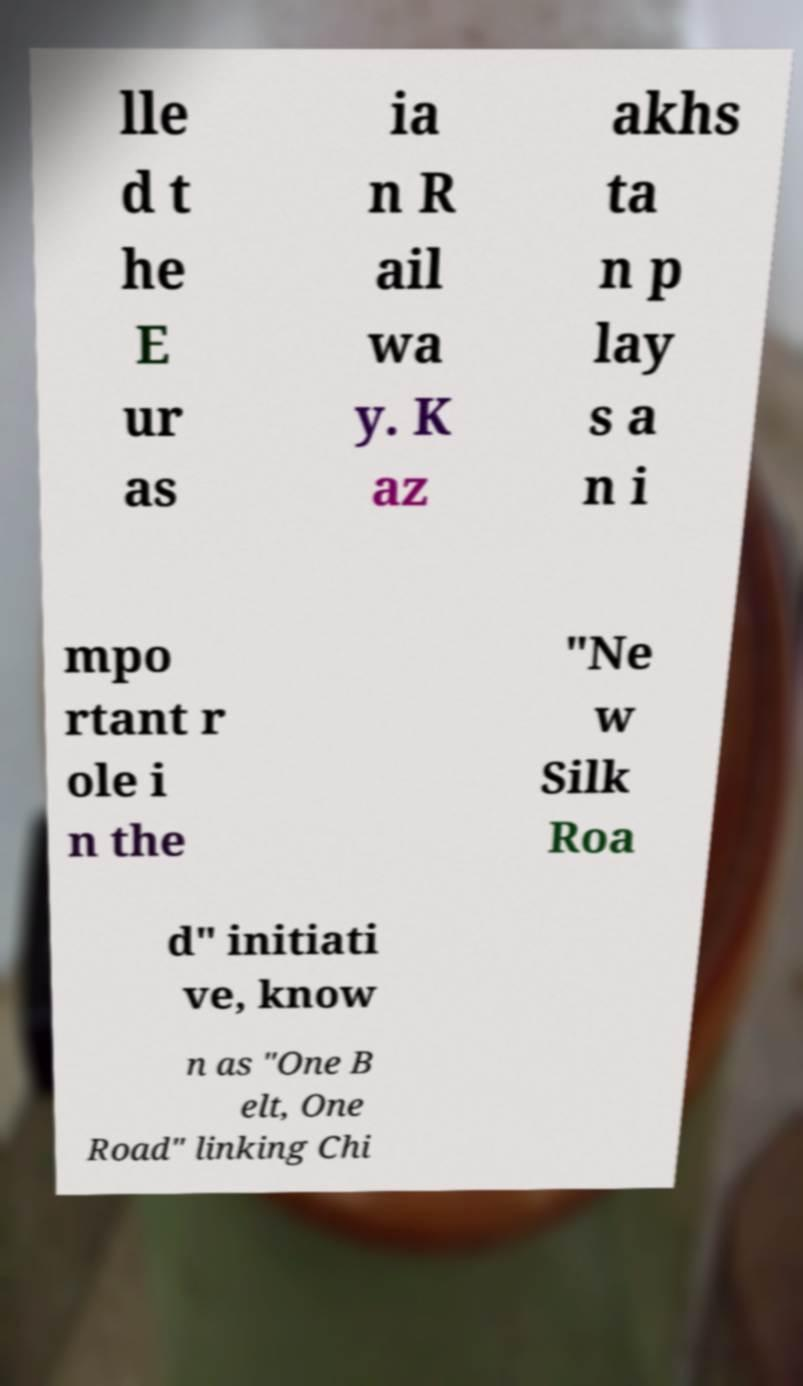Please read and relay the text visible in this image. What does it say? lle d t he E ur as ia n R ail wa y. K az akhs ta n p lay s a n i mpo rtant r ole i n the "Ne w Silk Roa d" initiati ve, know n as "One B elt, One Road" linking Chi 